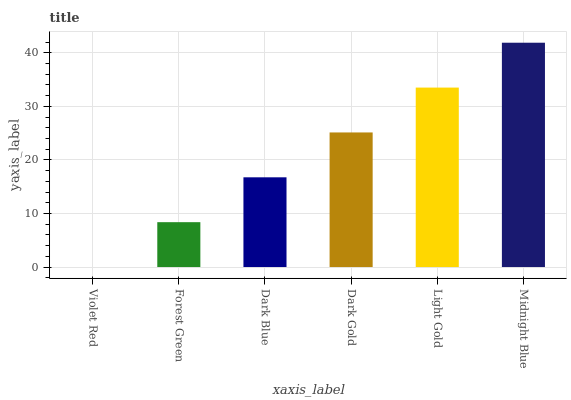Is Forest Green the minimum?
Answer yes or no. No. Is Forest Green the maximum?
Answer yes or no. No. Is Forest Green greater than Violet Red?
Answer yes or no. Yes. Is Violet Red less than Forest Green?
Answer yes or no. Yes. Is Violet Red greater than Forest Green?
Answer yes or no. No. Is Forest Green less than Violet Red?
Answer yes or no. No. Is Dark Gold the high median?
Answer yes or no. Yes. Is Dark Blue the low median?
Answer yes or no. Yes. Is Light Gold the high median?
Answer yes or no. No. Is Light Gold the low median?
Answer yes or no. No. 